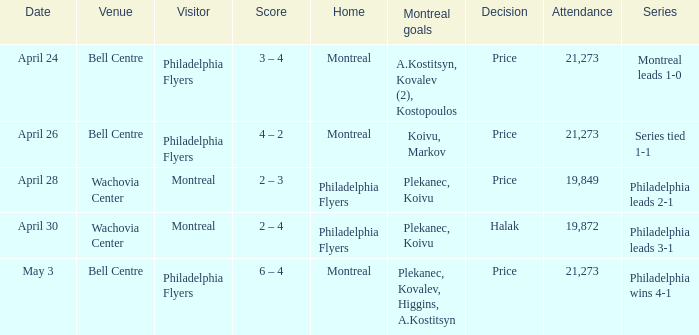What was the average attendance when the decision was price and montreal were the visitors? 19849.0. 